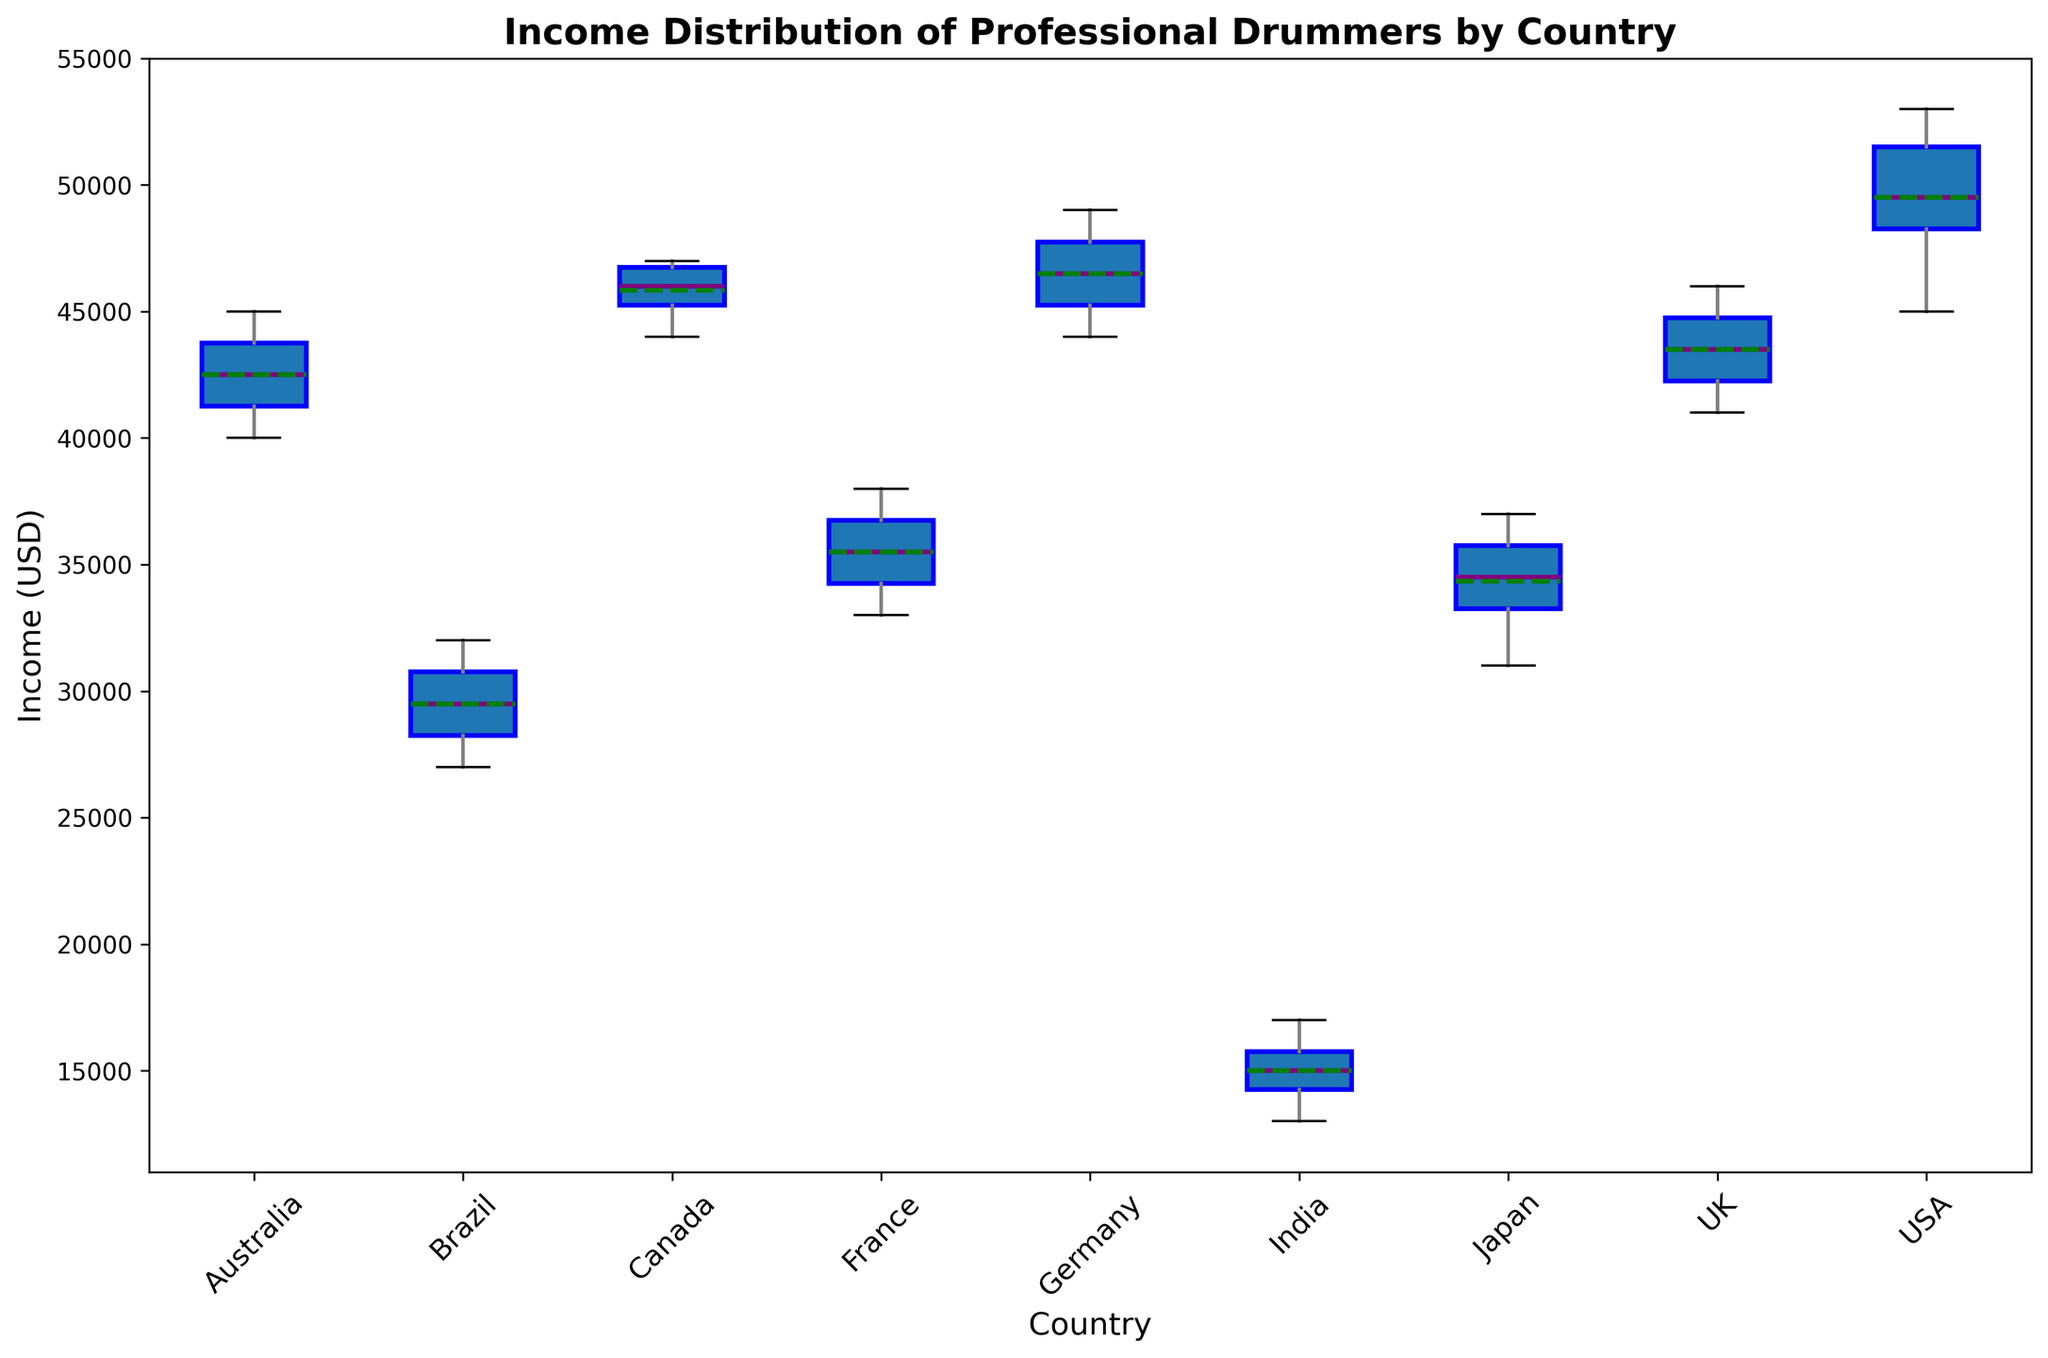What's the median income for professional drummers in the USA? To find the median income, look at the line inside the box for the USA. This line represents the median value.
Answer: 50000 Which country has the lowest range of income distribution? The range of income distribution for each country can be identified by the length of the box (interquartile range). The country with the shortest box has the lowest range.
Answer: India Compare the mean incomes of professional drummers in Japan and Brazil. Which one is higher? The mean is represented by the green line in the box plot. Check the height of the green line for both Japan and Brazil to compare.
Answer: Brazil What are the lower and upper whiskers for professional drummers in Germany? The whiskers are the lines extending from the top and bottom of the box. For Germany, find the endpoints of the whiskers.
Answer: Lower: 44000, Upper: 49000 How does the median income in Canada compare to that in the UK? Compare the median line inside the boxes for Canada and the UK. Determine which line is higher or if they are equal.
Answer: Higher in Canada Which country has the highest median income for professional drummers? The highest median income can be found by looking for the highest median line across all countries.
Answer: USA Which country shows the widest income distribution range? The country with the longest whiskers or box represents the widest income distribution range.
Answer: Australia Are there any outliers in the income distribution for professional drummers in France? Outliers are typically shown as individual points outside the whiskers. Check for any such points for France.
Answer: No Examine the income distributions in Brazil and India. Who earns less on average? Compare the median lines (middle of the boxes) of Brazil and India. The lower line represents a lower average income.
Answer: India What color are the outlier points in the box plot? Outliers are represented by points with a specific color, as per the plot design.
Answer: Red 